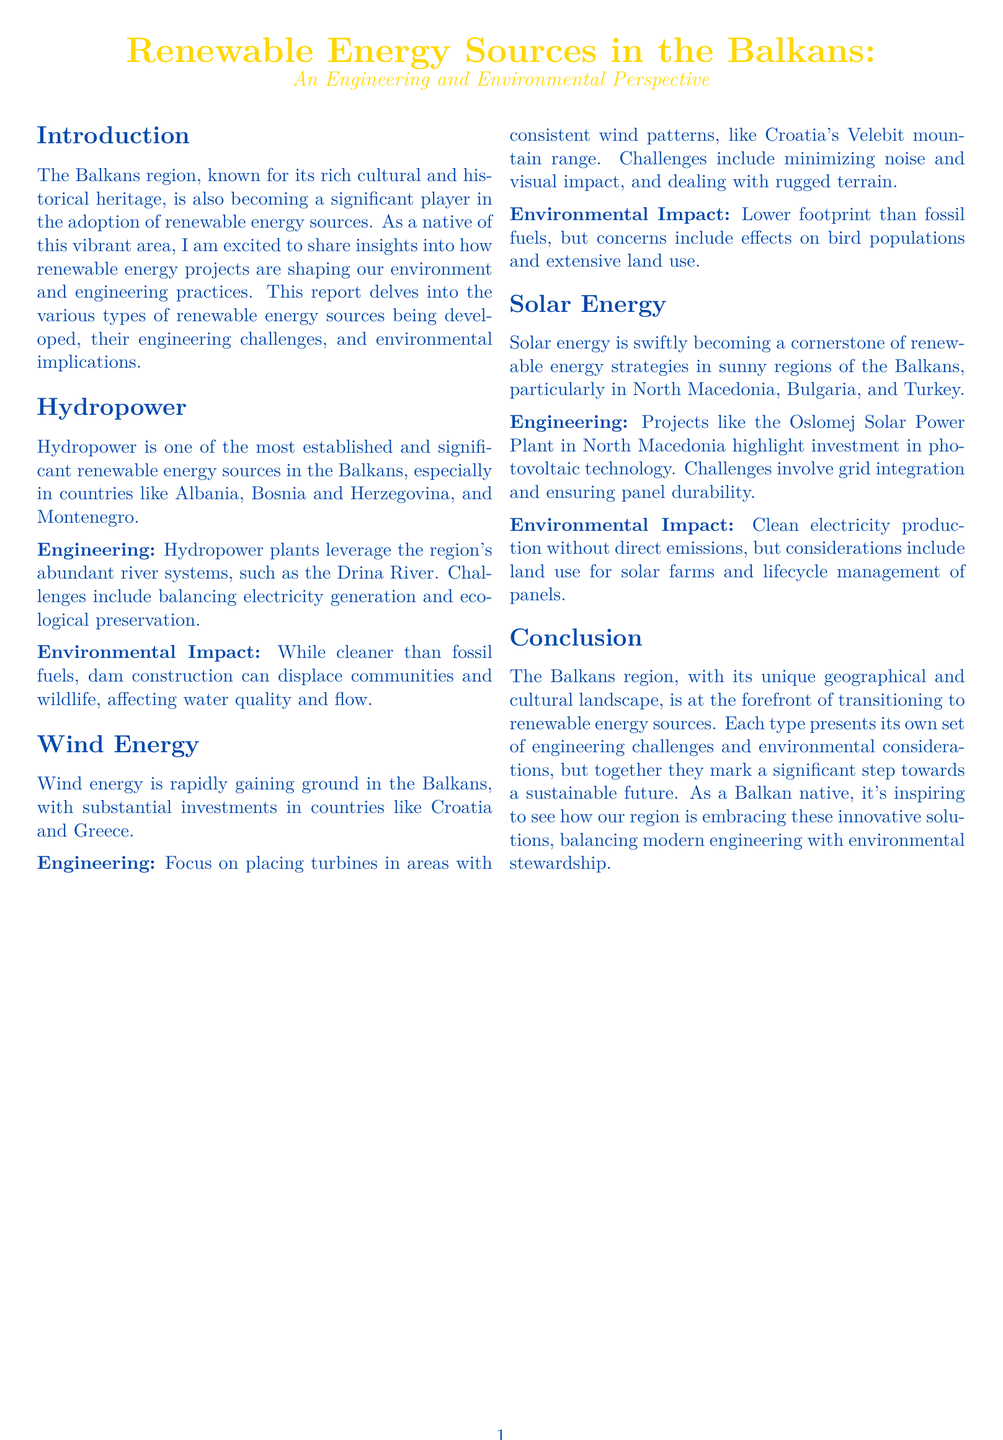What is the main focus of the report? The report delves into renewable energy sources being developed in the Balkans, their engineering challenges, and environmental implications.
Answer: Renewable energy sources Which countries are noted for hydropower development? The report identifies specific countries that leverage hydropower, expressing their significance in the region.
Answer: Albania, Bosnia and Herzegovina, Montenegro What is a primary engineering challenge of hydropower plants? The document discusses the balance that needs to be achieved between two critical aspects of hydropower operations.
Answer: Balancing electricity generation and ecological preservation Where is wind energy particularly gaining investment? The report outlines specific countries showing notable investments in wind energy projects.
Answer: Croatia, Greece What renewable energy technology is highlighted for North Macedonia? The document mentions an important solar energy project that exemplifies investment in a specific technology within the region.
Answer: Photovoltaic technology What environmental impact does dam construction have? This impact is specifically described in the context of balancing human and ecological systems in the report.
Answer: Displace communities and wildlife Which mountain range in Croatia is mentioned in relation to wind energy? The document specifies a geographic feature that serves a significant role in wind energy engineering efforts in Croatia.
Answer: Velebit mountain range What is the conclusion about the Balkans' transition to renewable energy? The report's conclusion emphasizes a broader theme about the region's approach to renewable energy in relation to engineering and the environment.
Answer: A significant step towards a sustainable future 